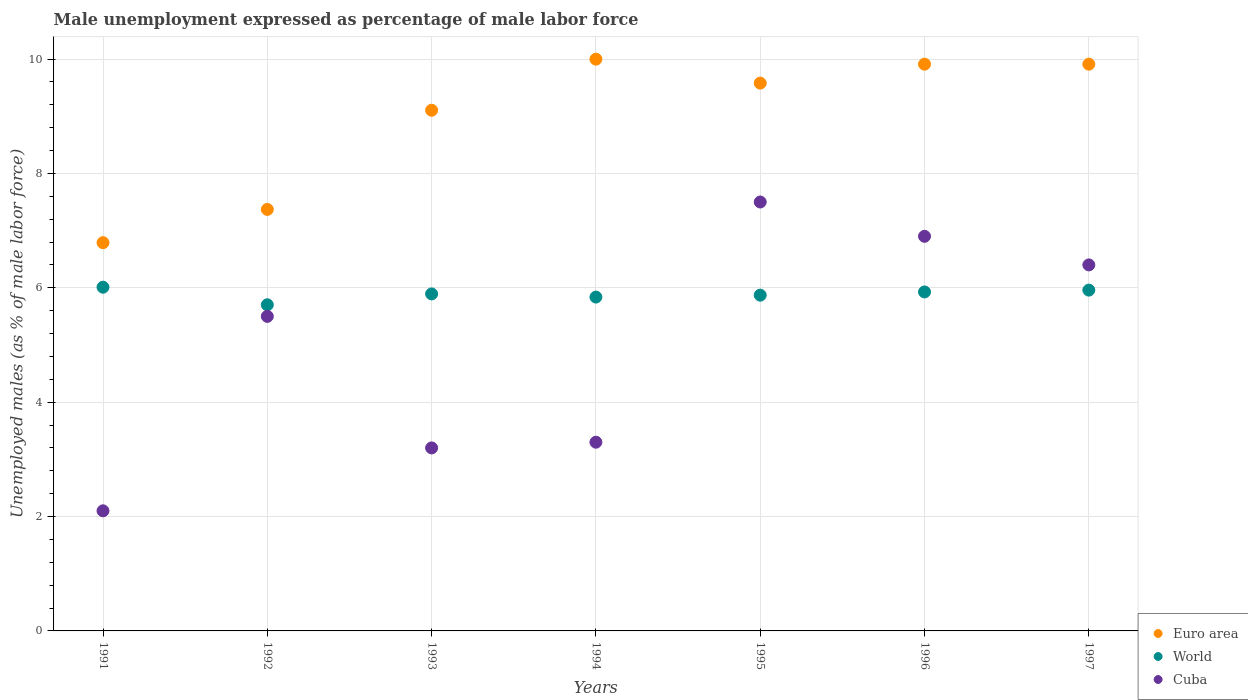What is the unemployment in males in in World in 1995?
Offer a terse response. 5.87. Across all years, what is the maximum unemployment in males in in World?
Provide a succinct answer. 6.01. Across all years, what is the minimum unemployment in males in in Euro area?
Offer a terse response. 6.79. What is the total unemployment in males in in Euro area in the graph?
Make the answer very short. 62.66. What is the difference between the unemployment in males in in Euro area in 1995 and that in 1997?
Your response must be concise. -0.33. What is the difference between the unemployment in males in in World in 1993 and the unemployment in males in in Cuba in 1992?
Offer a very short reply. 0.39. What is the average unemployment in males in in Cuba per year?
Make the answer very short. 4.99. In the year 1995, what is the difference between the unemployment in males in in Euro area and unemployment in males in in Cuba?
Keep it short and to the point. 2.08. What is the ratio of the unemployment in males in in Euro area in 1993 to that in 1994?
Ensure brevity in your answer.  0.91. Is the difference between the unemployment in males in in Euro area in 1991 and 1996 greater than the difference between the unemployment in males in in Cuba in 1991 and 1996?
Keep it short and to the point. Yes. What is the difference between the highest and the second highest unemployment in males in in World?
Offer a terse response. 0.05. What is the difference between the highest and the lowest unemployment in males in in World?
Keep it short and to the point. 0.31. In how many years, is the unemployment in males in in Euro area greater than the average unemployment in males in in Euro area taken over all years?
Provide a short and direct response. 5. Is it the case that in every year, the sum of the unemployment in males in in World and unemployment in males in in Cuba  is greater than the unemployment in males in in Euro area?
Give a very brief answer. No. How many dotlines are there?
Ensure brevity in your answer.  3. How many years are there in the graph?
Ensure brevity in your answer.  7. What is the difference between two consecutive major ticks on the Y-axis?
Offer a very short reply. 2. Where does the legend appear in the graph?
Provide a succinct answer. Bottom right. What is the title of the graph?
Give a very brief answer. Male unemployment expressed as percentage of male labor force. Does "Georgia" appear as one of the legend labels in the graph?
Your response must be concise. No. What is the label or title of the Y-axis?
Offer a very short reply. Unemployed males (as % of male labor force). What is the Unemployed males (as % of male labor force) in Euro area in 1991?
Your answer should be compact. 6.79. What is the Unemployed males (as % of male labor force) in World in 1991?
Your answer should be very brief. 6.01. What is the Unemployed males (as % of male labor force) in Cuba in 1991?
Your answer should be very brief. 2.1. What is the Unemployed males (as % of male labor force) of Euro area in 1992?
Provide a short and direct response. 7.37. What is the Unemployed males (as % of male labor force) of World in 1992?
Offer a very short reply. 5.7. What is the Unemployed males (as % of male labor force) in Euro area in 1993?
Your response must be concise. 9.1. What is the Unemployed males (as % of male labor force) in World in 1993?
Your answer should be compact. 5.89. What is the Unemployed males (as % of male labor force) of Cuba in 1993?
Provide a succinct answer. 3.2. What is the Unemployed males (as % of male labor force) of Euro area in 1994?
Provide a succinct answer. 10. What is the Unemployed males (as % of male labor force) of World in 1994?
Make the answer very short. 5.84. What is the Unemployed males (as % of male labor force) in Cuba in 1994?
Your answer should be compact. 3.3. What is the Unemployed males (as % of male labor force) of Euro area in 1995?
Offer a very short reply. 9.58. What is the Unemployed males (as % of male labor force) in World in 1995?
Make the answer very short. 5.87. What is the Unemployed males (as % of male labor force) of Cuba in 1995?
Ensure brevity in your answer.  7.5. What is the Unemployed males (as % of male labor force) in Euro area in 1996?
Your answer should be compact. 9.91. What is the Unemployed males (as % of male labor force) of World in 1996?
Give a very brief answer. 5.93. What is the Unemployed males (as % of male labor force) in Cuba in 1996?
Your answer should be compact. 6.9. What is the Unemployed males (as % of male labor force) in Euro area in 1997?
Keep it short and to the point. 9.91. What is the Unemployed males (as % of male labor force) in World in 1997?
Offer a very short reply. 5.96. What is the Unemployed males (as % of male labor force) of Cuba in 1997?
Provide a succinct answer. 6.4. Across all years, what is the maximum Unemployed males (as % of male labor force) of Euro area?
Your answer should be very brief. 10. Across all years, what is the maximum Unemployed males (as % of male labor force) in World?
Offer a very short reply. 6.01. Across all years, what is the maximum Unemployed males (as % of male labor force) of Cuba?
Provide a short and direct response. 7.5. Across all years, what is the minimum Unemployed males (as % of male labor force) of Euro area?
Make the answer very short. 6.79. Across all years, what is the minimum Unemployed males (as % of male labor force) in World?
Give a very brief answer. 5.7. Across all years, what is the minimum Unemployed males (as % of male labor force) of Cuba?
Keep it short and to the point. 2.1. What is the total Unemployed males (as % of male labor force) of Euro area in the graph?
Your answer should be compact. 62.66. What is the total Unemployed males (as % of male labor force) of World in the graph?
Ensure brevity in your answer.  41.2. What is the total Unemployed males (as % of male labor force) in Cuba in the graph?
Provide a succinct answer. 34.9. What is the difference between the Unemployed males (as % of male labor force) of Euro area in 1991 and that in 1992?
Offer a terse response. -0.58. What is the difference between the Unemployed males (as % of male labor force) of World in 1991 and that in 1992?
Provide a succinct answer. 0.31. What is the difference between the Unemployed males (as % of male labor force) in Euro area in 1991 and that in 1993?
Ensure brevity in your answer.  -2.32. What is the difference between the Unemployed males (as % of male labor force) in World in 1991 and that in 1993?
Your response must be concise. 0.12. What is the difference between the Unemployed males (as % of male labor force) of Cuba in 1991 and that in 1993?
Your response must be concise. -1.1. What is the difference between the Unemployed males (as % of male labor force) in Euro area in 1991 and that in 1994?
Make the answer very short. -3.21. What is the difference between the Unemployed males (as % of male labor force) of World in 1991 and that in 1994?
Offer a very short reply. 0.17. What is the difference between the Unemployed males (as % of male labor force) in Euro area in 1991 and that in 1995?
Ensure brevity in your answer.  -2.79. What is the difference between the Unemployed males (as % of male labor force) of World in 1991 and that in 1995?
Your answer should be compact. 0.14. What is the difference between the Unemployed males (as % of male labor force) in Cuba in 1991 and that in 1995?
Provide a succinct answer. -5.4. What is the difference between the Unemployed males (as % of male labor force) in Euro area in 1991 and that in 1996?
Provide a succinct answer. -3.12. What is the difference between the Unemployed males (as % of male labor force) in World in 1991 and that in 1996?
Offer a terse response. 0.08. What is the difference between the Unemployed males (as % of male labor force) of Cuba in 1991 and that in 1996?
Offer a very short reply. -4.8. What is the difference between the Unemployed males (as % of male labor force) in Euro area in 1991 and that in 1997?
Offer a terse response. -3.12. What is the difference between the Unemployed males (as % of male labor force) of World in 1991 and that in 1997?
Provide a succinct answer. 0.05. What is the difference between the Unemployed males (as % of male labor force) of Euro area in 1992 and that in 1993?
Your answer should be very brief. -1.73. What is the difference between the Unemployed males (as % of male labor force) of World in 1992 and that in 1993?
Make the answer very short. -0.19. What is the difference between the Unemployed males (as % of male labor force) of Cuba in 1992 and that in 1993?
Make the answer very short. 2.3. What is the difference between the Unemployed males (as % of male labor force) in Euro area in 1992 and that in 1994?
Keep it short and to the point. -2.63. What is the difference between the Unemployed males (as % of male labor force) of World in 1992 and that in 1994?
Keep it short and to the point. -0.13. What is the difference between the Unemployed males (as % of male labor force) in Euro area in 1992 and that in 1995?
Make the answer very short. -2.21. What is the difference between the Unemployed males (as % of male labor force) in World in 1992 and that in 1995?
Your response must be concise. -0.17. What is the difference between the Unemployed males (as % of male labor force) in Euro area in 1992 and that in 1996?
Provide a short and direct response. -2.54. What is the difference between the Unemployed males (as % of male labor force) in World in 1992 and that in 1996?
Provide a succinct answer. -0.22. What is the difference between the Unemployed males (as % of male labor force) in Cuba in 1992 and that in 1996?
Give a very brief answer. -1.4. What is the difference between the Unemployed males (as % of male labor force) of Euro area in 1992 and that in 1997?
Offer a terse response. -2.54. What is the difference between the Unemployed males (as % of male labor force) in World in 1992 and that in 1997?
Make the answer very short. -0.26. What is the difference between the Unemployed males (as % of male labor force) of Euro area in 1993 and that in 1994?
Your response must be concise. -0.89. What is the difference between the Unemployed males (as % of male labor force) of World in 1993 and that in 1994?
Your answer should be very brief. 0.06. What is the difference between the Unemployed males (as % of male labor force) in Cuba in 1993 and that in 1994?
Provide a short and direct response. -0.1. What is the difference between the Unemployed males (as % of male labor force) in Euro area in 1993 and that in 1995?
Ensure brevity in your answer.  -0.47. What is the difference between the Unemployed males (as % of male labor force) in World in 1993 and that in 1995?
Offer a very short reply. 0.02. What is the difference between the Unemployed males (as % of male labor force) in Euro area in 1993 and that in 1996?
Offer a terse response. -0.81. What is the difference between the Unemployed males (as % of male labor force) of World in 1993 and that in 1996?
Provide a short and direct response. -0.03. What is the difference between the Unemployed males (as % of male labor force) of Euro area in 1993 and that in 1997?
Provide a succinct answer. -0.81. What is the difference between the Unemployed males (as % of male labor force) of World in 1993 and that in 1997?
Offer a terse response. -0.07. What is the difference between the Unemployed males (as % of male labor force) in Cuba in 1993 and that in 1997?
Offer a terse response. -3.2. What is the difference between the Unemployed males (as % of male labor force) of Euro area in 1994 and that in 1995?
Your answer should be very brief. 0.42. What is the difference between the Unemployed males (as % of male labor force) of World in 1994 and that in 1995?
Ensure brevity in your answer.  -0.03. What is the difference between the Unemployed males (as % of male labor force) of Cuba in 1994 and that in 1995?
Keep it short and to the point. -4.2. What is the difference between the Unemployed males (as % of male labor force) of Euro area in 1994 and that in 1996?
Provide a short and direct response. 0.09. What is the difference between the Unemployed males (as % of male labor force) in World in 1994 and that in 1996?
Keep it short and to the point. -0.09. What is the difference between the Unemployed males (as % of male labor force) of Cuba in 1994 and that in 1996?
Ensure brevity in your answer.  -3.6. What is the difference between the Unemployed males (as % of male labor force) of Euro area in 1994 and that in 1997?
Make the answer very short. 0.09. What is the difference between the Unemployed males (as % of male labor force) of World in 1994 and that in 1997?
Give a very brief answer. -0.12. What is the difference between the Unemployed males (as % of male labor force) of Cuba in 1994 and that in 1997?
Keep it short and to the point. -3.1. What is the difference between the Unemployed males (as % of male labor force) in Euro area in 1995 and that in 1996?
Ensure brevity in your answer.  -0.33. What is the difference between the Unemployed males (as % of male labor force) in World in 1995 and that in 1996?
Your answer should be very brief. -0.06. What is the difference between the Unemployed males (as % of male labor force) of Cuba in 1995 and that in 1996?
Give a very brief answer. 0.6. What is the difference between the Unemployed males (as % of male labor force) of Euro area in 1995 and that in 1997?
Keep it short and to the point. -0.33. What is the difference between the Unemployed males (as % of male labor force) of World in 1995 and that in 1997?
Make the answer very short. -0.09. What is the difference between the Unemployed males (as % of male labor force) of Euro area in 1996 and that in 1997?
Your response must be concise. 0. What is the difference between the Unemployed males (as % of male labor force) in World in 1996 and that in 1997?
Provide a short and direct response. -0.03. What is the difference between the Unemployed males (as % of male labor force) of Euro area in 1991 and the Unemployed males (as % of male labor force) of World in 1992?
Make the answer very short. 1.09. What is the difference between the Unemployed males (as % of male labor force) of Euro area in 1991 and the Unemployed males (as % of male labor force) of Cuba in 1992?
Offer a very short reply. 1.29. What is the difference between the Unemployed males (as % of male labor force) in World in 1991 and the Unemployed males (as % of male labor force) in Cuba in 1992?
Offer a very short reply. 0.51. What is the difference between the Unemployed males (as % of male labor force) in Euro area in 1991 and the Unemployed males (as % of male labor force) in World in 1993?
Give a very brief answer. 0.9. What is the difference between the Unemployed males (as % of male labor force) in Euro area in 1991 and the Unemployed males (as % of male labor force) in Cuba in 1993?
Your answer should be very brief. 3.59. What is the difference between the Unemployed males (as % of male labor force) in World in 1991 and the Unemployed males (as % of male labor force) in Cuba in 1993?
Your answer should be very brief. 2.81. What is the difference between the Unemployed males (as % of male labor force) in Euro area in 1991 and the Unemployed males (as % of male labor force) in World in 1994?
Your answer should be very brief. 0.95. What is the difference between the Unemployed males (as % of male labor force) of Euro area in 1991 and the Unemployed males (as % of male labor force) of Cuba in 1994?
Make the answer very short. 3.49. What is the difference between the Unemployed males (as % of male labor force) in World in 1991 and the Unemployed males (as % of male labor force) in Cuba in 1994?
Keep it short and to the point. 2.71. What is the difference between the Unemployed males (as % of male labor force) of Euro area in 1991 and the Unemployed males (as % of male labor force) of World in 1995?
Your response must be concise. 0.92. What is the difference between the Unemployed males (as % of male labor force) in Euro area in 1991 and the Unemployed males (as % of male labor force) in Cuba in 1995?
Your answer should be compact. -0.71. What is the difference between the Unemployed males (as % of male labor force) of World in 1991 and the Unemployed males (as % of male labor force) of Cuba in 1995?
Your answer should be compact. -1.49. What is the difference between the Unemployed males (as % of male labor force) of Euro area in 1991 and the Unemployed males (as % of male labor force) of World in 1996?
Provide a short and direct response. 0.86. What is the difference between the Unemployed males (as % of male labor force) of Euro area in 1991 and the Unemployed males (as % of male labor force) of Cuba in 1996?
Ensure brevity in your answer.  -0.11. What is the difference between the Unemployed males (as % of male labor force) of World in 1991 and the Unemployed males (as % of male labor force) of Cuba in 1996?
Keep it short and to the point. -0.89. What is the difference between the Unemployed males (as % of male labor force) in Euro area in 1991 and the Unemployed males (as % of male labor force) in World in 1997?
Your response must be concise. 0.83. What is the difference between the Unemployed males (as % of male labor force) of Euro area in 1991 and the Unemployed males (as % of male labor force) of Cuba in 1997?
Provide a succinct answer. 0.39. What is the difference between the Unemployed males (as % of male labor force) in World in 1991 and the Unemployed males (as % of male labor force) in Cuba in 1997?
Offer a terse response. -0.39. What is the difference between the Unemployed males (as % of male labor force) in Euro area in 1992 and the Unemployed males (as % of male labor force) in World in 1993?
Ensure brevity in your answer.  1.48. What is the difference between the Unemployed males (as % of male labor force) in Euro area in 1992 and the Unemployed males (as % of male labor force) in Cuba in 1993?
Offer a terse response. 4.17. What is the difference between the Unemployed males (as % of male labor force) of World in 1992 and the Unemployed males (as % of male labor force) of Cuba in 1993?
Offer a terse response. 2.5. What is the difference between the Unemployed males (as % of male labor force) in Euro area in 1992 and the Unemployed males (as % of male labor force) in World in 1994?
Your response must be concise. 1.53. What is the difference between the Unemployed males (as % of male labor force) of Euro area in 1992 and the Unemployed males (as % of male labor force) of Cuba in 1994?
Offer a terse response. 4.07. What is the difference between the Unemployed males (as % of male labor force) in World in 1992 and the Unemployed males (as % of male labor force) in Cuba in 1994?
Provide a short and direct response. 2.4. What is the difference between the Unemployed males (as % of male labor force) in Euro area in 1992 and the Unemployed males (as % of male labor force) in World in 1995?
Provide a short and direct response. 1.5. What is the difference between the Unemployed males (as % of male labor force) in Euro area in 1992 and the Unemployed males (as % of male labor force) in Cuba in 1995?
Your answer should be very brief. -0.13. What is the difference between the Unemployed males (as % of male labor force) in World in 1992 and the Unemployed males (as % of male labor force) in Cuba in 1995?
Ensure brevity in your answer.  -1.8. What is the difference between the Unemployed males (as % of male labor force) in Euro area in 1992 and the Unemployed males (as % of male labor force) in World in 1996?
Your response must be concise. 1.44. What is the difference between the Unemployed males (as % of male labor force) in Euro area in 1992 and the Unemployed males (as % of male labor force) in Cuba in 1996?
Keep it short and to the point. 0.47. What is the difference between the Unemployed males (as % of male labor force) in World in 1992 and the Unemployed males (as % of male labor force) in Cuba in 1996?
Offer a terse response. -1.2. What is the difference between the Unemployed males (as % of male labor force) in Euro area in 1992 and the Unemployed males (as % of male labor force) in World in 1997?
Offer a terse response. 1.41. What is the difference between the Unemployed males (as % of male labor force) in Euro area in 1992 and the Unemployed males (as % of male labor force) in Cuba in 1997?
Offer a very short reply. 0.97. What is the difference between the Unemployed males (as % of male labor force) of World in 1992 and the Unemployed males (as % of male labor force) of Cuba in 1997?
Keep it short and to the point. -0.7. What is the difference between the Unemployed males (as % of male labor force) in Euro area in 1993 and the Unemployed males (as % of male labor force) in World in 1994?
Give a very brief answer. 3.27. What is the difference between the Unemployed males (as % of male labor force) of Euro area in 1993 and the Unemployed males (as % of male labor force) of Cuba in 1994?
Your response must be concise. 5.8. What is the difference between the Unemployed males (as % of male labor force) in World in 1993 and the Unemployed males (as % of male labor force) in Cuba in 1994?
Ensure brevity in your answer.  2.59. What is the difference between the Unemployed males (as % of male labor force) of Euro area in 1993 and the Unemployed males (as % of male labor force) of World in 1995?
Provide a short and direct response. 3.23. What is the difference between the Unemployed males (as % of male labor force) in Euro area in 1993 and the Unemployed males (as % of male labor force) in Cuba in 1995?
Keep it short and to the point. 1.6. What is the difference between the Unemployed males (as % of male labor force) in World in 1993 and the Unemployed males (as % of male labor force) in Cuba in 1995?
Your response must be concise. -1.61. What is the difference between the Unemployed males (as % of male labor force) in Euro area in 1993 and the Unemployed males (as % of male labor force) in World in 1996?
Provide a short and direct response. 3.18. What is the difference between the Unemployed males (as % of male labor force) in Euro area in 1993 and the Unemployed males (as % of male labor force) in Cuba in 1996?
Keep it short and to the point. 2.2. What is the difference between the Unemployed males (as % of male labor force) in World in 1993 and the Unemployed males (as % of male labor force) in Cuba in 1996?
Your response must be concise. -1.01. What is the difference between the Unemployed males (as % of male labor force) of Euro area in 1993 and the Unemployed males (as % of male labor force) of World in 1997?
Provide a short and direct response. 3.15. What is the difference between the Unemployed males (as % of male labor force) of Euro area in 1993 and the Unemployed males (as % of male labor force) of Cuba in 1997?
Your answer should be compact. 2.7. What is the difference between the Unemployed males (as % of male labor force) in World in 1993 and the Unemployed males (as % of male labor force) in Cuba in 1997?
Make the answer very short. -0.51. What is the difference between the Unemployed males (as % of male labor force) in Euro area in 1994 and the Unemployed males (as % of male labor force) in World in 1995?
Provide a succinct answer. 4.13. What is the difference between the Unemployed males (as % of male labor force) of Euro area in 1994 and the Unemployed males (as % of male labor force) of Cuba in 1995?
Ensure brevity in your answer.  2.5. What is the difference between the Unemployed males (as % of male labor force) of World in 1994 and the Unemployed males (as % of male labor force) of Cuba in 1995?
Your answer should be very brief. -1.66. What is the difference between the Unemployed males (as % of male labor force) of Euro area in 1994 and the Unemployed males (as % of male labor force) of World in 1996?
Provide a short and direct response. 4.07. What is the difference between the Unemployed males (as % of male labor force) of Euro area in 1994 and the Unemployed males (as % of male labor force) of Cuba in 1996?
Offer a very short reply. 3.1. What is the difference between the Unemployed males (as % of male labor force) in World in 1994 and the Unemployed males (as % of male labor force) in Cuba in 1996?
Your response must be concise. -1.06. What is the difference between the Unemployed males (as % of male labor force) in Euro area in 1994 and the Unemployed males (as % of male labor force) in World in 1997?
Keep it short and to the point. 4.04. What is the difference between the Unemployed males (as % of male labor force) in Euro area in 1994 and the Unemployed males (as % of male labor force) in Cuba in 1997?
Your answer should be very brief. 3.6. What is the difference between the Unemployed males (as % of male labor force) of World in 1994 and the Unemployed males (as % of male labor force) of Cuba in 1997?
Your answer should be compact. -0.56. What is the difference between the Unemployed males (as % of male labor force) of Euro area in 1995 and the Unemployed males (as % of male labor force) of World in 1996?
Provide a succinct answer. 3.65. What is the difference between the Unemployed males (as % of male labor force) in Euro area in 1995 and the Unemployed males (as % of male labor force) in Cuba in 1996?
Your answer should be compact. 2.68. What is the difference between the Unemployed males (as % of male labor force) of World in 1995 and the Unemployed males (as % of male labor force) of Cuba in 1996?
Make the answer very short. -1.03. What is the difference between the Unemployed males (as % of male labor force) in Euro area in 1995 and the Unemployed males (as % of male labor force) in World in 1997?
Provide a short and direct response. 3.62. What is the difference between the Unemployed males (as % of male labor force) in Euro area in 1995 and the Unemployed males (as % of male labor force) in Cuba in 1997?
Ensure brevity in your answer.  3.18. What is the difference between the Unemployed males (as % of male labor force) of World in 1995 and the Unemployed males (as % of male labor force) of Cuba in 1997?
Offer a very short reply. -0.53. What is the difference between the Unemployed males (as % of male labor force) in Euro area in 1996 and the Unemployed males (as % of male labor force) in World in 1997?
Your response must be concise. 3.95. What is the difference between the Unemployed males (as % of male labor force) of Euro area in 1996 and the Unemployed males (as % of male labor force) of Cuba in 1997?
Ensure brevity in your answer.  3.51. What is the difference between the Unemployed males (as % of male labor force) of World in 1996 and the Unemployed males (as % of male labor force) of Cuba in 1997?
Your response must be concise. -0.47. What is the average Unemployed males (as % of male labor force) in Euro area per year?
Offer a very short reply. 8.95. What is the average Unemployed males (as % of male labor force) in World per year?
Your answer should be very brief. 5.89. What is the average Unemployed males (as % of male labor force) in Cuba per year?
Provide a short and direct response. 4.99. In the year 1991, what is the difference between the Unemployed males (as % of male labor force) of Euro area and Unemployed males (as % of male labor force) of World?
Your answer should be compact. 0.78. In the year 1991, what is the difference between the Unemployed males (as % of male labor force) in Euro area and Unemployed males (as % of male labor force) in Cuba?
Ensure brevity in your answer.  4.69. In the year 1991, what is the difference between the Unemployed males (as % of male labor force) of World and Unemployed males (as % of male labor force) of Cuba?
Make the answer very short. 3.91. In the year 1992, what is the difference between the Unemployed males (as % of male labor force) of Euro area and Unemployed males (as % of male labor force) of World?
Give a very brief answer. 1.67. In the year 1992, what is the difference between the Unemployed males (as % of male labor force) in Euro area and Unemployed males (as % of male labor force) in Cuba?
Keep it short and to the point. 1.87. In the year 1992, what is the difference between the Unemployed males (as % of male labor force) of World and Unemployed males (as % of male labor force) of Cuba?
Ensure brevity in your answer.  0.2. In the year 1993, what is the difference between the Unemployed males (as % of male labor force) in Euro area and Unemployed males (as % of male labor force) in World?
Give a very brief answer. 3.21. In the year 1993, what is the difference between the Unemployed males (as % of male labor force) of Euro area and Unemployed males (as % of male labor force) of Cuba?
Give a very brief answer. 5.9. In the year 1993, what is the difference between the Unemployed males (as % of male labor force) of World and Unemployed males (as % of male labor force) of Cuba?
Offer a terse response. 2.69. In the year 1994, what is the difference between the Unemployed males (as % of male labor force) of Euro area and Unemployed males (as % of male labor force) of World?
Provide a succinct answer. 4.16. In the year 1994, what is the difference between the Unemployed males (as % of male labor force) of Euro area and Unemployed males (as % of male labor force) of Cuba?
Provide a succinct answer. 6.7. In the year 1994, what is the difference between the Unemployed males (as % of male labor force) of World and Unemployed males (as % of male labor force) of Cuba?
Your answer should be compact. 2.54. In the year 1995, what is the difference between the Unemployed males (as % of male labor force) of Euro area and Unemployed males (as % of male labor force) of World?
Your response must be concise. 3.71. In the year 1995, what is the difference between the Unemployed males (as % of male labor force) of Euro area and Unemployed males (as % of male labor force) of Cuba?
Your response must be concise. 2.08. In the year 1995, what is the difference between the Unemployed males (as % of male labor force) in World and Unemployed males (as % of male labor force) in Cuba?
Make the answer very short. -1.63. In the year 1996, what is the difference between the Unemployed males (as % of male labor force) of Euro area and Unemployed males (as % of male labor force) of World?
Your answer should be compact. 3.98. In the year 1996, what is the difference between the Unemployed males (as % of male labor force) of Euro area and Unemployed males (as % of male labor force) of Cuba?
Your response must be concise. 3.01. In the year 1996, what is the difference between the Unemployed males (as % of male labor force) in World and Unemployed males (as % of male labor force) in Cuba?
Offer a very short reply. -0.97. In the year 1997, what is the difference between the Unemployed males (as % of male labor force) in Euro area and Unemployed males (as % of male labor force) in World?
Your answer should be compact. 3.95. In the year 1997, what is the difference between the Unemployed males (as % of male labor force) of Euro area and Unemployed males (as % of male labor force) of Cuba?
Ensure brevity in your answer.  3.51. In the year 1997, what is the difference between the Unemployed males (as % of male labor force) in World and Unemployed males (as % of male labor force) in Cuba?
Make the answer very short. -0.44. What is the ratio of the Unemployed males (as % of male labor force) in Euro area in 1991 to that in 1992?
Provide a short and direct response. 0.92. What is the ratio of the Unemployed males (as % of male labor force) in World in 1991 to that in 1992?
Keep it short and to the point. 1.05. What is the ratio of the Unemployed males (as % of male labor force) of Cuba in 1991 to that in 1992?
Provide a succinct answer. 0.38. What is the ratio of the Unemployed males (as % of male labor force) in Euro area in 1991 to that in 1993?
Offer a terse response. 0.75. What is the ratio of the Unemployed males (as % of male labor force) in World in 1991 to that in 1993?
Your response must be concise. 1.02. What is the ratio of the Unemployed males (as % of male labor force) in Cuba in 1991 to that in 1993?
Give a very brief answer. 0.66. What is the ratio of the Unemployed males (as % of male labor force) of Euro area in 1991 to that in 1994?
Your response must be concise. 0.68. What is the ratio of the Unemployed males (as % of male labor force) in World in 1991 to that in 1994?
Keep it short and to the point. 1.03. What is the ratio of the Unemployed males (as % of male labor force) of Cuba in 1991 to that in 1994?
Offer a very short reply. 0.64. What is the ratio of the Unemployed males (as % of male labor force) of Euro area in 1991 to that in 1995?
Your response must be concise. 0.71. What is the ratio of the Unemployed males (as % of male labor force) of World in 1991 to that in 1995?
Your response must be concise. 1.02. What is the ratio of the Unemployed males (as % of male labor force) in Cuba in 1991 to that in 1995?
Make the answer very short. 0.28. What is the ratio of the Unemployed males (as % of male labor force) in Euro area in 1991 to that in 1996?
Provide a short and direct response. 0.69. What is the ratio of the Unemployed males (as % of male labor force) of World in 1991 to that in 1996?
Offer a very short reply. 1.01. What is the ratio of the Unemployed males (as % of male labor force) in Cuba in 1991 to that in 1996?
Your response must be concise. 0.3. What is the ratio of the Unemployed males (as % of male labor force) of Euro area in 1991 to that in 1997?
Provide a short and direct response. 0.69. What is the ratio of the Unemployed males (as % of male labor force) of World in 1991 to that in 1997?
Make the answer very short. 1.01. What is the ratio of the Unemployed males (as % of male labor force) of Cuba in 1991 to that in 1997?
Your response must be concise. 0.33. What is the ratio of the Unemployed males (as % of male labor force) of Euro area in 1992 to that in 1993?
Your answer should be very brief. 0.81. What is the ratio of the Unemployed males (as % of male labor force) in Cuba in 1992 to that in 1993?
Offer a very short reply. 1.72. What is the ratio of the Unemployed males (as % of male labor force) in Euro area in 1992 to that in 1994?
Your answer should be very brief. 0.74. What is the ratio of the Unemployed males (as % of male labor force) of World in 1992 to that in 1994?
Provide a succinct answer. 0.98. What is the ratio of the Unemployed males (as % of male labor force) of Cuba in 1992 to that in 1994?
Your response must be concise. 1.67. What is the ratio of the Unemployed males (as % of male labor force) of Euro area in 1992 to that in 1995?
Keep it short and to the point. 0.77. What is the ratio of the Unemployed males (as % of male labor force) in World in 1992 to that in 1995?
Your answer should be very brief. 0.97. What is the ratio of the Unemployed males (as % of male labor force) in Cuba in 1992 to that in 1995?
Your answer should be compact. 0.73. What is the ratio of the Unemployed males (as % of male labor force) of Euro area in 1992 to that in 1996?
Your answer should be very brief. 0.74. What is the ratio of the Unemployed males (as % of male labor force) of World in 1992 to that in 1996?
Provide a succinct answer. 0.96. What is the ratio of the Unemployed males (as % of male labor force) in Cuba in 1992 to that in 1996?
Your response must be concise. 0.8. What is the ratio of the Unemployed males (as % of male labor force) in Euro area in 1992 to that in 1997?
Your response must be concise. 0.74. What is the ratio of the Unemployed males (as % of male labor force) of World in 1992 to that in 1997?
Your response must be concise. 0.96. What is the ratio of the Unemployed males (as % of male labor force) in Cuba in 1992 to that in 1997?
Ensure brevity in your answer.  0.86. What is the ratio of the Unemployed males (as % of male labor force) of Euro area in 1993 to that in 1994?
Your answer should be very brief. 0.91. What is the ratio of the Unemployed males (as % of male labor force) in World in 1993 to that in 1994?
Keep it short and to the point. 1.01. What is the ratio of the Unemployed males (as % of male labor force) in Cuba in 1993 to that in 1994?
Your response must be concise. 0.97. What is the ratio of the Unemployed males (as % of male labor force) of Euro area in 1993 to that in 1995?
Provide a succinct answer. 0.95. What is the ratio of the Unemployed males (as % of male labor force) in Cuba in 1993 to that in 1995?
Make the answer very short. 0.43. What is the ratio of the Unemployed males (as % of male labor force) in Euro area in 1993 to that in 1996?
Ensure brevity in your answer.  0.92. What is the ratio of the Unemployed males (as % of male labor force) in Cuba in 1993 to that in 1996?
Provide a succinct answer. 0.46. What is the ratio of the Unemployed males (as % of male labor force) in Euro area in 1993 to that in 1997?
Offer a terse response. 0.92. What is the ratio of the Unemployed males (as % of male labor force) of World in 1993 to that in 1997?
Ensure brevity in your answer.  0.99. What is the ratio of the Unemployed males (as % of male labor force) in Cuba in 1993 to that in 1997?
Your response must be concise. 0.5. What is the ratio of the Unemployed males (as % of male labor force) in Euro area in 1994 to that in 1995?
Offer a terse response. 1.04. What is the ratio of the Unemployed males (as % of male labor force) of World in 1994 to that in 1995?
Make the answer very short. 0.99. What is the ratio of the Unemployed males (as % of male labor force) in Cuba in 1994 to that in 1995?
Make the answer very short. 0.44. What is the ratio of the Unemployed males (as % of male labor force) in Euro area in 1994 to that in 1996?
Provide a succinct answer. 1.01. What is the ratio of the Unemployed males (as % of male labor force) of World in 1994 to that in 1996?
Offer a very short reply. 0.98. What is the ratio of the Unemployed males (as % of male labor force) in Cuba in 1994 to that in 1996?
Your answer should be very brief. 0.48. What is the ratio of the Unemployed males (as % of male labor force) in Euro area in 1994 to that in 1997?
Offer a very short reply. 1.01. What is the ratio of the Unemployed males (as % of male labor force) in World in 1994 to that in 1997?
Your response must be concise. 0.98. What is the ratio of the Unemployed males (as % of male labor force) of Cuba in 1994 to that in 1997?
Make the answer very short. 0.52. What is the ratio of the Unemployed males (as % of male labor force) of Euro area in 1995 to that in 1996?
Provide a short and direct response. 0.97. What is the ratio of the Unemployed males (as % of male labor force) of Cuba in 1995 to that in 1996?
Offer a terse response. 1.09. What is the ratio of the Unemployed males (as % of male labor force) of Euro area in 1995 to that in 1997?
Provide a succinct answer. 0.97. What is the ratio of the Unemployed males (as % of male labor force) in World in 1995 to that in 1997?
Your answer should be compact. 0.99. What is the ratio of the Unemployed males (as % of male labor force) in Cuba in 1995 to that in 1997?
Provide a succinct answer. 1.17. What is the ratio of the Unemployed males (as % of male labor force) in Euro area in 1996 to that in 1997?
Your answer should be compact. 1. What is the ratio of the Unemployed males (as % of male labor force) of World in 1996 to that in 1997?
Offer a very short reply. 0.99. What is the ratio of the Unemployed males (as % of male labor force) in Cuba in 1996 to that in 1997?
Offer a very short reply. 1.08. What is the difference between the highest and the second highest Unemployed males (as % of male labor force) of Euro area?
Provide a short and direct response. 0.09. What is the difference between the highest and the second highest Unemployed males (as % of male labor force) in World?
Give a very brief answer. 0.05. What is the difference between the highest and the second highest Unemployed males (as % of male labor force) of Cuba?
Offer a terse response. 0.6. What is the difference between the highest and the lowest Unemployed males (as % of male labor force) of Euro area?
Offer a very short reply. 3.21. What is the difference between the highest and the lowest Unemployed males (as % of male labor force) in World?
Offer a very short reply. 0.31. What is the difference between the highest and the lowest Unemployed males (as % of male labor force) in Cuba?
Ensure brevity in your answer.  5.4. 